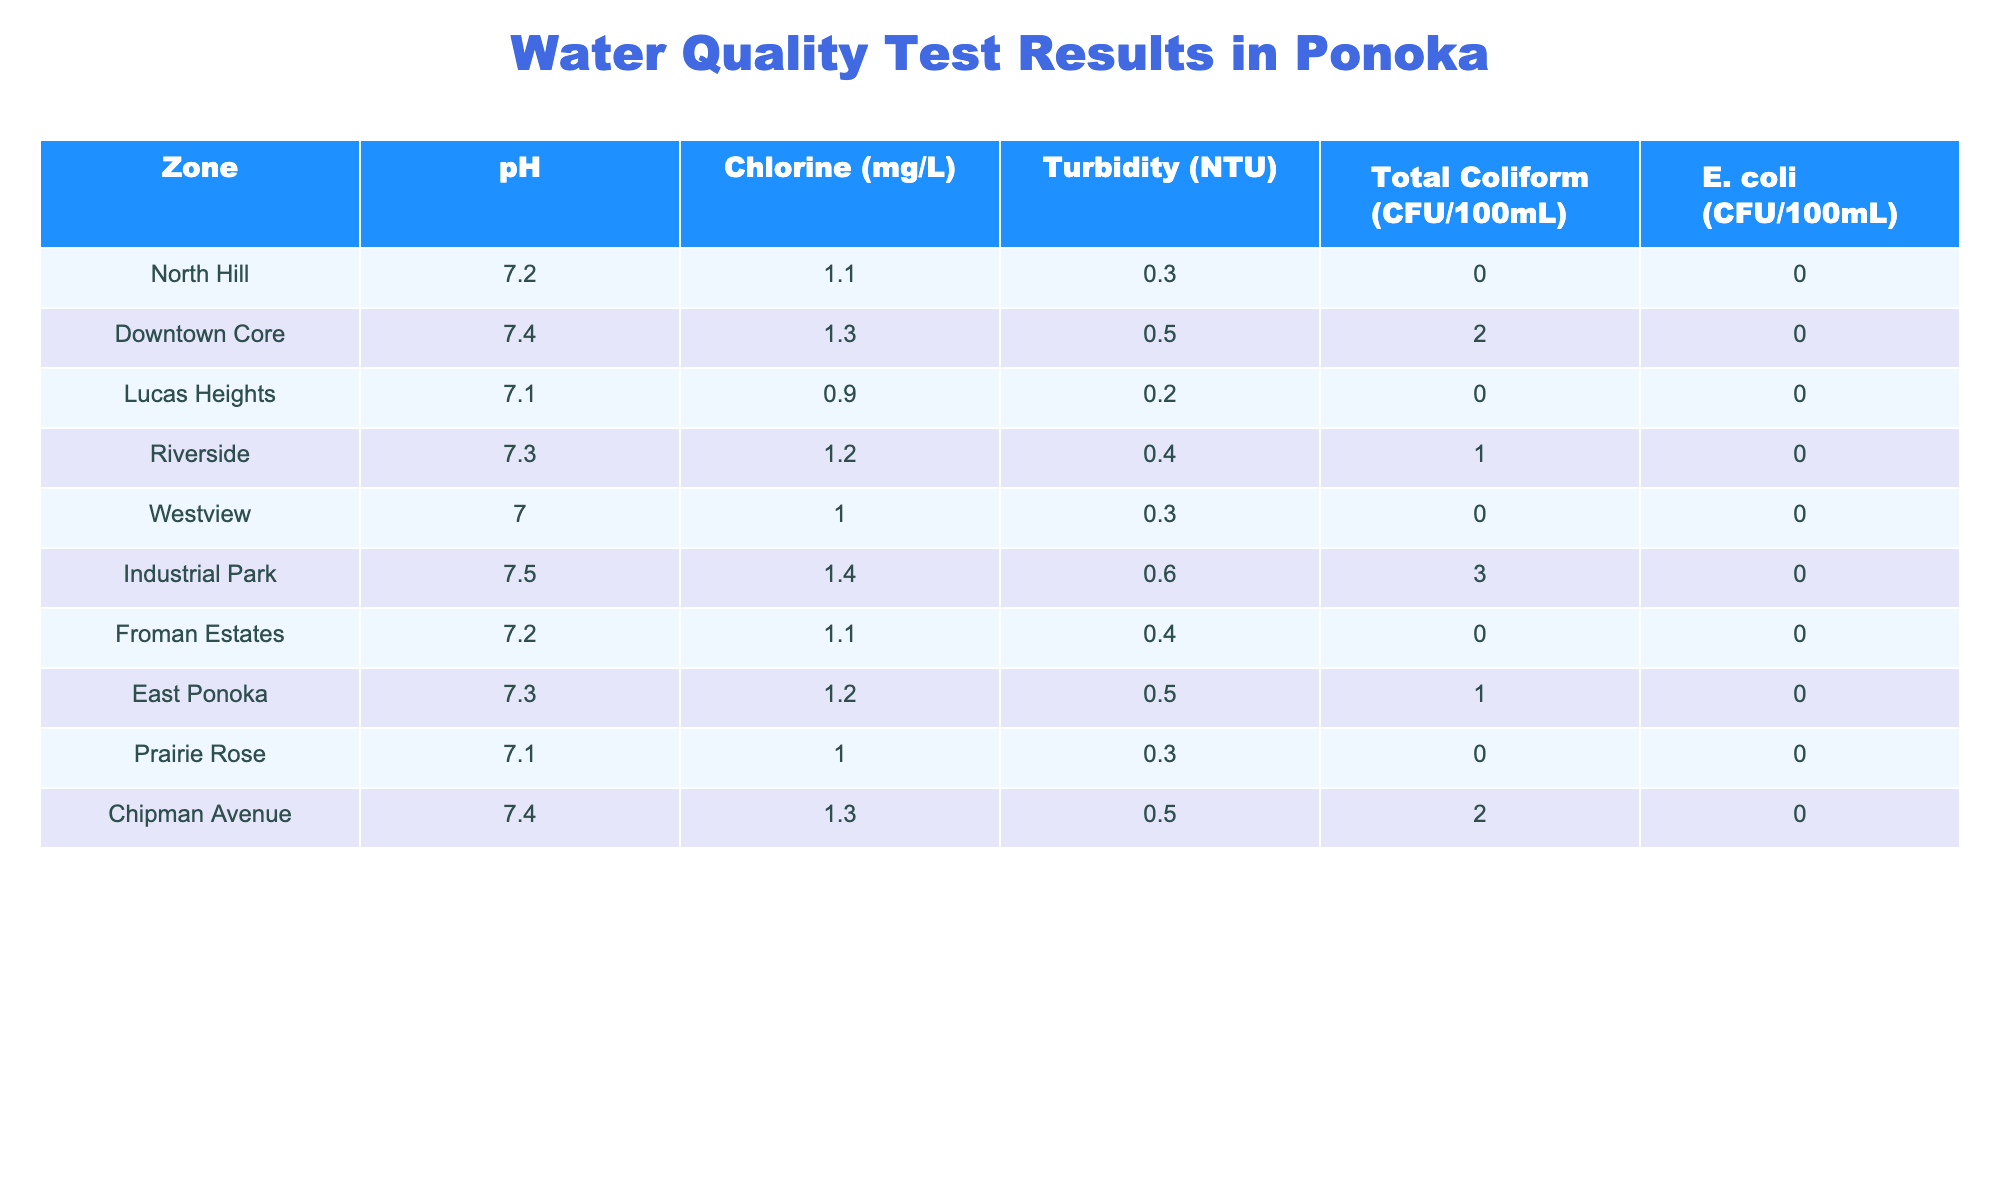What is the pH value of the water in the North Hill zone? The table shows that the pH value listed for the North Hill zone is 7.2.
Answer: 7.2 Which zone has the highest Chlorine level? By comparing the Chlorine levels across all zones, Industrial Park has the highest level at 1.4 mg/L.
Answer: Industrial Park What is the Total Coliform count in the Downtown Core? The Total Coliform count for the Downtown Core zone is 2 CFU/100mL according to the table.
Answer: 2 CFU/100mL Which zones have a pH level below 7.2? The zones with a pH level below 7.2 are Westview (7.0) and Lucas Heights (7.1).
Answer: Westview, Lucas Heights Calculate the average Turbidity across all the zones. To find the average Turbidity, add all the Turbidity values (0.3 + 0.5 + 0.2 + 0.4 + 0.3 + 0.6 + 0.4 + 0.5 + 0.3 + 0.5 = 3.8) and divide by the number of zones (10). Thus, the average Turbidity is 3.8/10 = 0.38 NTU.
Answer: 0.38 NTU Are there any zones that show a presence of E. coli? Based on the table, all listed zones report 0 CFU/100mL for E. coli, indicating none of them show a presence.
Answer: No Which two zones have the closest pH levels? Upon reviewing the pH levels, Lucas Heights (7.1) and Prairie Rose (7.1) have the same value, making them the closest.
Answer: Lucas Heights, Prairie Rose What is the difference in Chlorine levels between the highest and lowest zones? The highest Chlorine level is in Industrial Park (1.4 mg/L) and the lowest is in Lucas Heights (0.9 mg/L). The difference is 1.4 - 0.9 = 0.5 mg/L.
Answer: 0.5 mg/L Is there any zone with a Total Coliform count of 0? Yes, the North Hill, Lucas Heights, Froman Estates, Prairie Rose, and Westview zones all have a Total Coliform count of 0 CFU/100mL.
Answer: Yes Which zone has the lowest Turbidity level? The zone with the lowest Turbidity level is Lucas Heights, with a value of 0.2 NTU.
Answer: Lucas Heights 